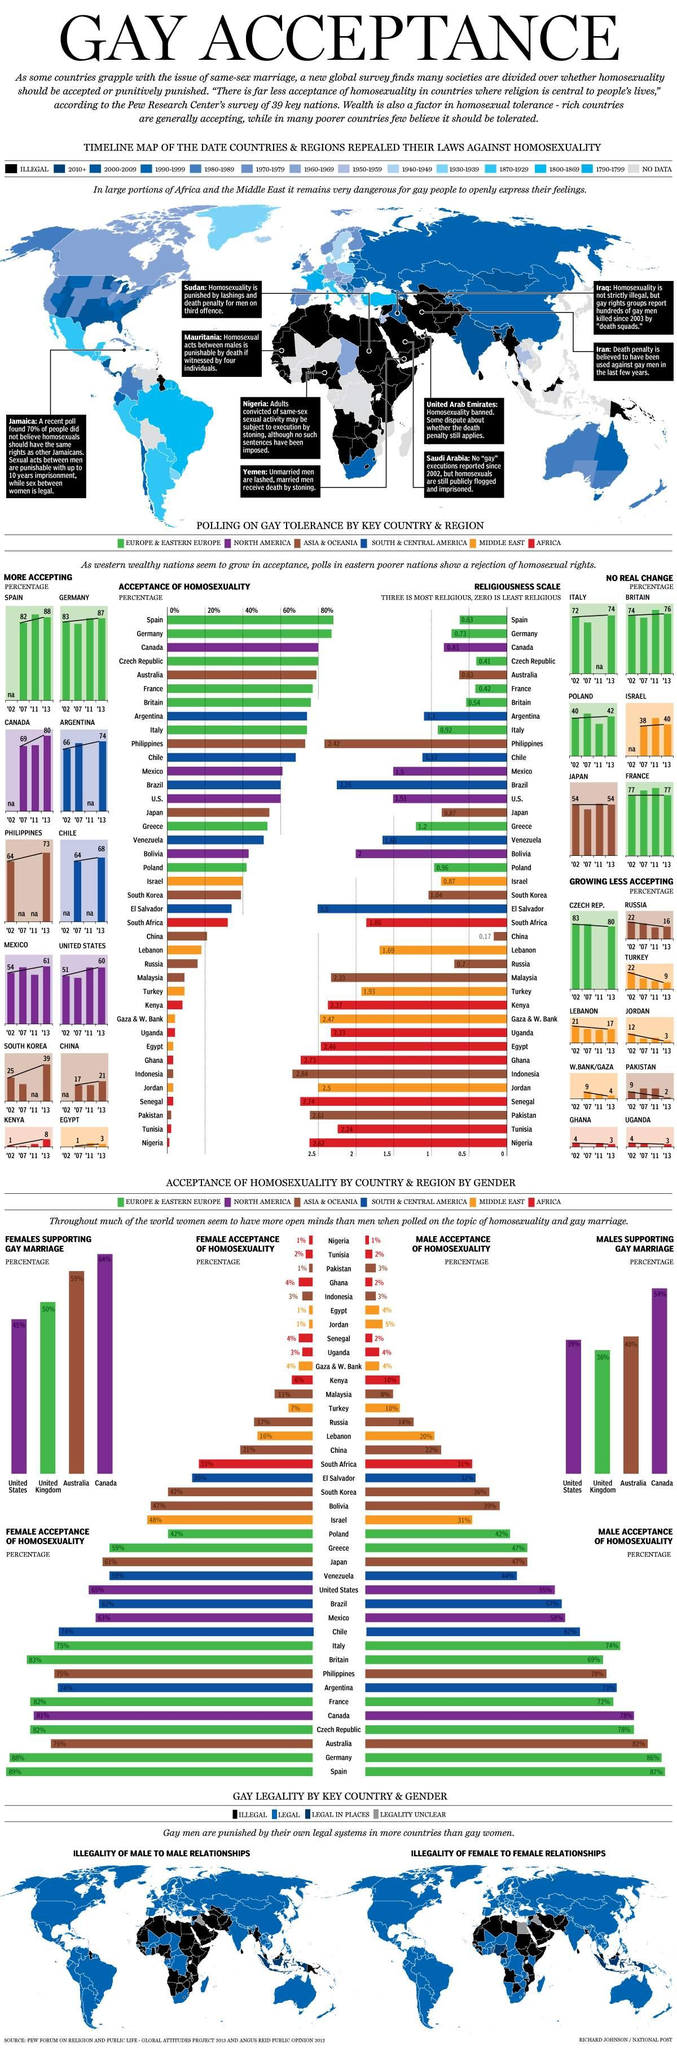Point out several critical features in this image. Germany has the second highest percentage of female acceptance of homosexuality among all countries. Spain has the highest percentage of male acceptance of homosexuality among all countries. According to data, Canada has the highest percentage of females who support gay marriage. In the United States, the percentage of females who support gay marriage is the lowest among all countries. Australia has the second highest percentage of females supporting gay marriage, according to a recent survey. 